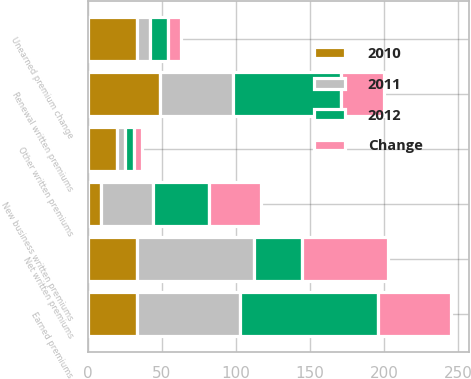Convert chart to OTSL. <chart><loc_0><loc_0><loc_500><loc_500><stacked_bar_chart><ecel><fcel>Renewal written premiums<fcel>New business written premiums<fcel>Other written premiums<fcel>Net written premiums<fcel>Unearned premium change<fcel>Earned premiums<nl><fcel>2012<fcel>73<fcel>38<fcel>6<fcel>33<fcel>12<fcel>93<nl><fcel>2011<fcel>49<fcel>35<fcel>5<fcel>79<fcel>9<fcel>70<nl><fcel>Change<fcel>29<fcel>35<fcel>6<fcel>58<fcel>9<fcel>49<nl><fcel>2010<fcel>49<fcel>9<fcel>20<fcel>33<fcel>33<fcel>33<nl></chart> 